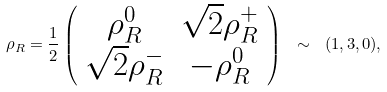<formula> <loc_0><loc_0><loc_500><loc_500>\rho _ { R } = \frac { 1 } { 2 } \left ( \begin{array} { c c } \rho _ { R } ^ { 0 } & \sqrt { 2 } \rho ^ { + } _ { R } \\ \sqrt { 2 } \rho ^ { - } _ { R } & - \rho _ { R } ^ { 0 } \end{array} \right ) \ \sim \ ( 1 , 3 , 0 ) ,</formula> 